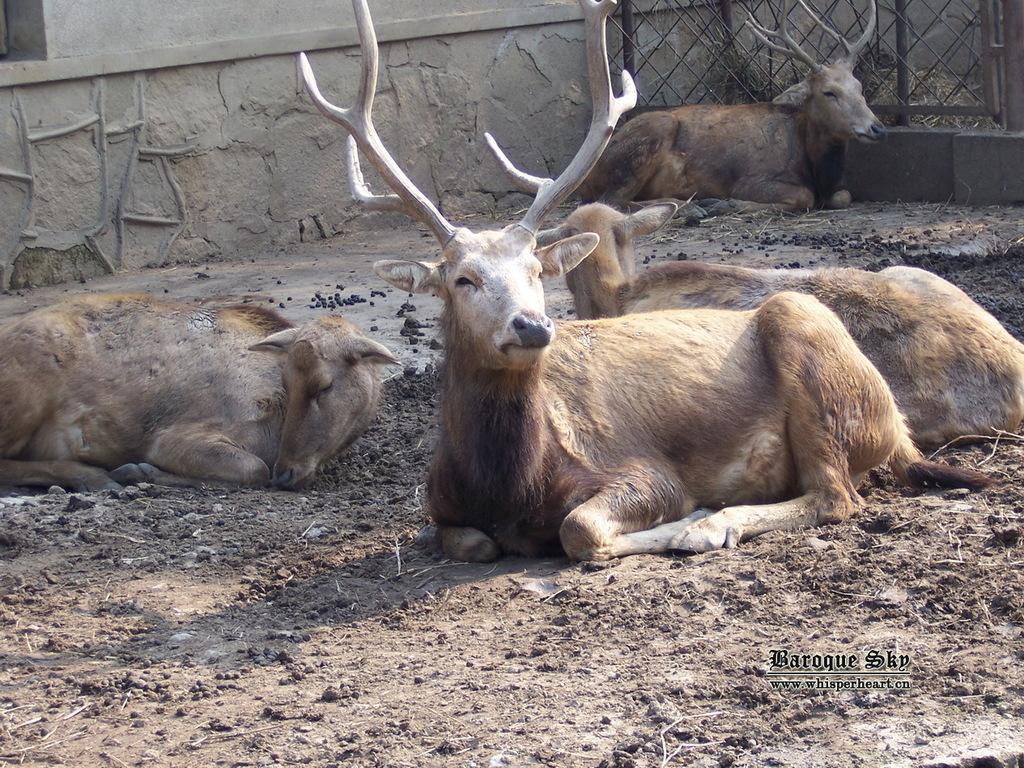How would you summarize this image in a sentence or two? In this image I can see few deer are sitting on the ground. In the background I can see the wall, fencing and on the bottom right side I can see a watermark. 